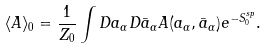Convert formula to latex. <formula><loc_0><loc_0><loc_500><loc_500>\langle { A } \rangle _ { 0 } = \frac { 1 } { Z _ { 0 } } \int { D a _ { \alpha } D \bar { a } _ { \alpha } A ( a _ { \alpha } , \bar { a } _ { \alpha } ) e ^ { - S _ { 0 } ^ { s p } } } .</formula> 